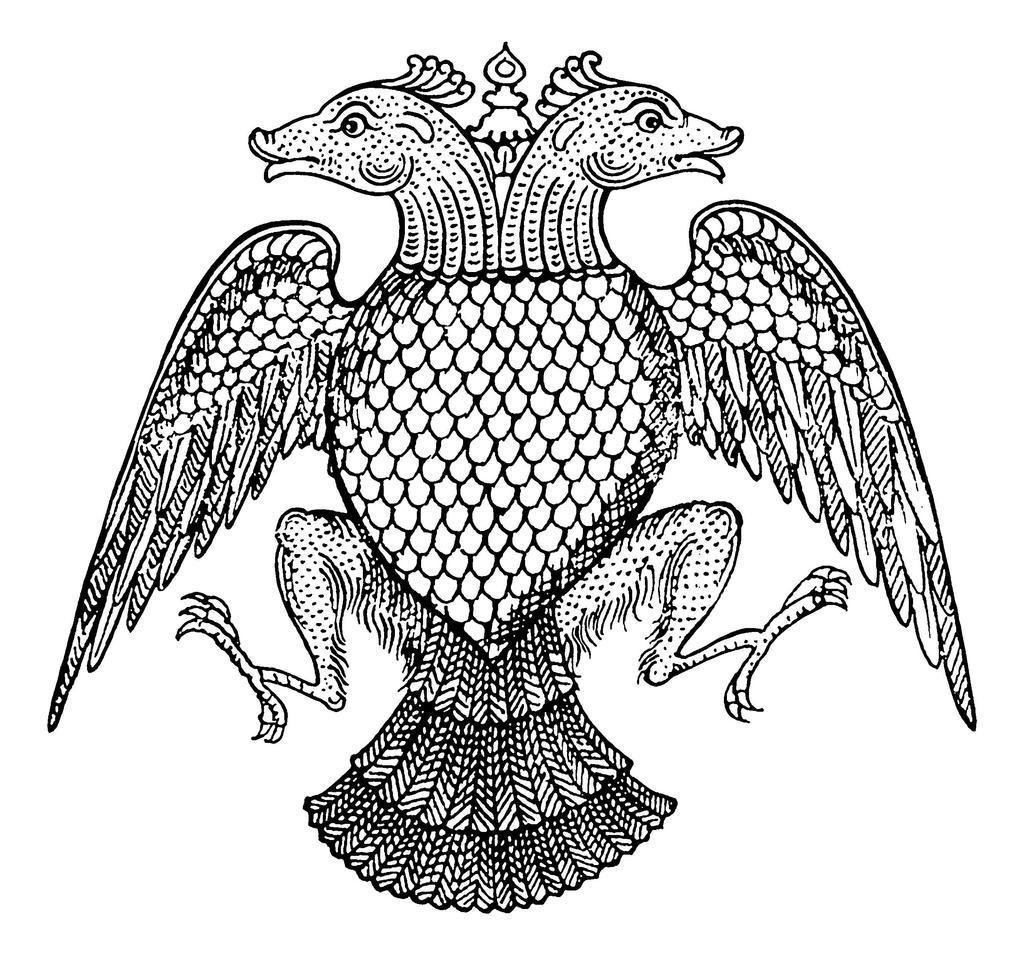Could you give a brief overview of what you see in this image? In this image we can see a picture. 